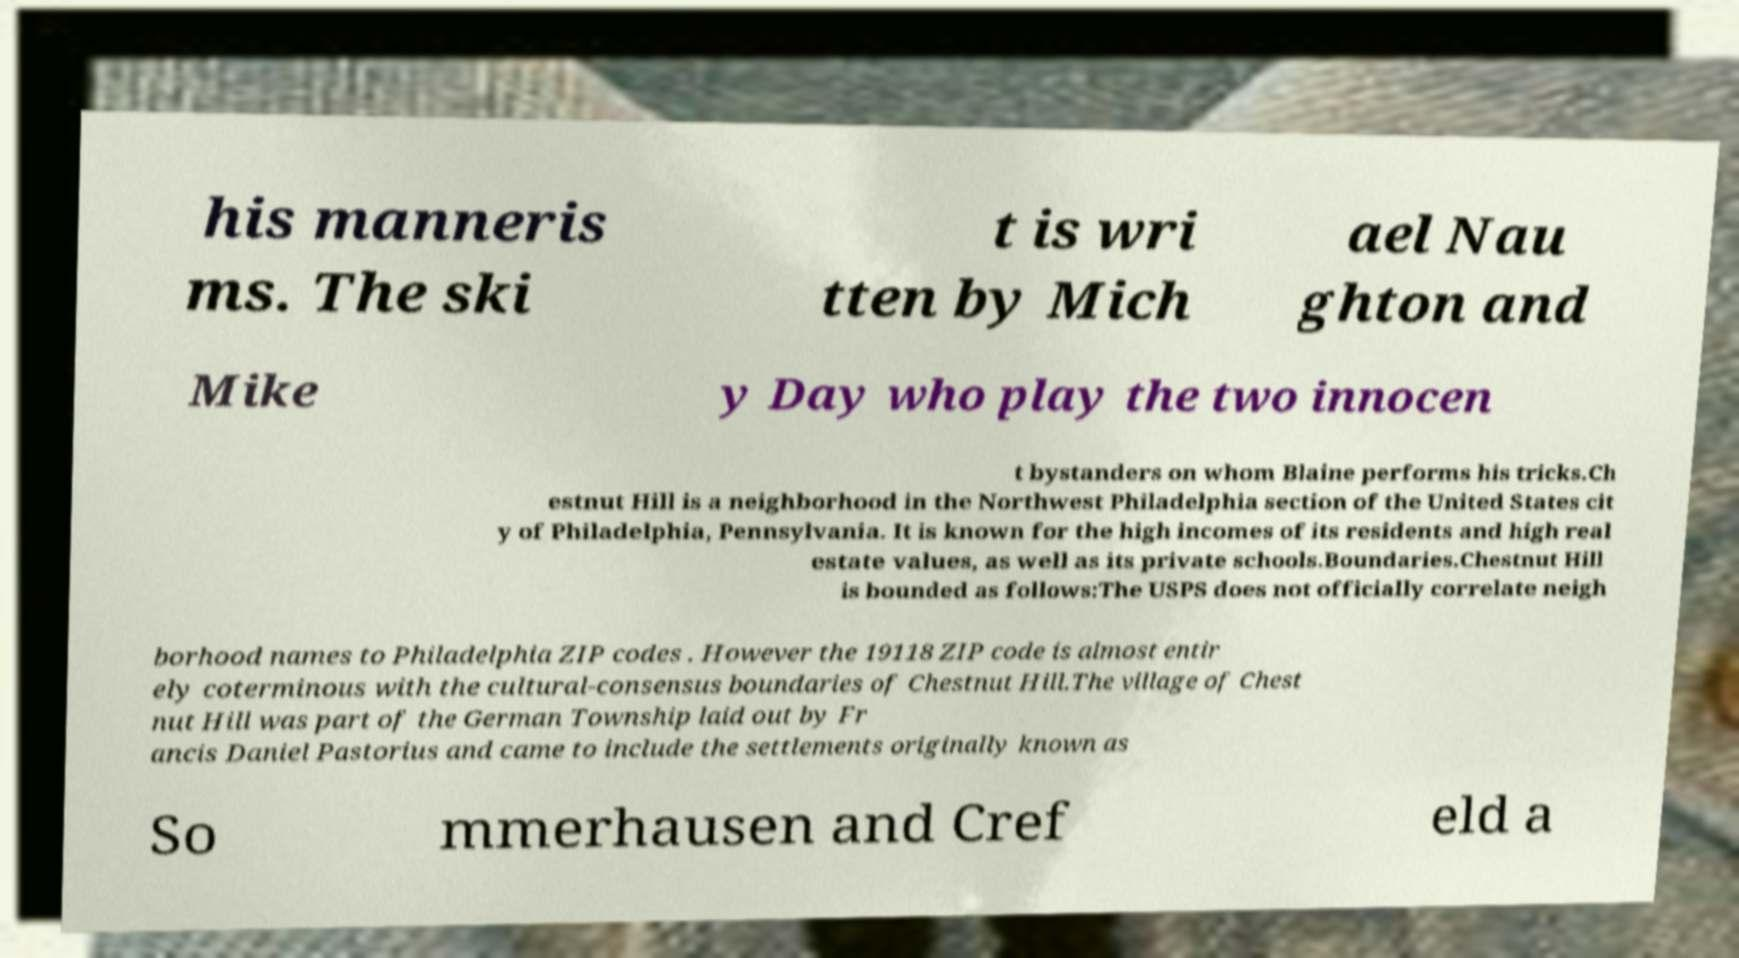Could you assist in decoding the text presented in this image and type it out clearly? his manneris ms. The ski t is wri tten by Mich ael Nau ghton and Mike y Day who play the two innocen t bystanders on whom Blaine performs his tricks.Ch estnut Hill is a neighborhood in the Northwest Philadelphia section of the United States cit y of Philadelphia, Pennsylvania. It is known for the high incomes of its residents and high real estate values, as well as its private schools.Boundaries.Chestnut Hill is bounded as follows:The USPS does not officially correlate neigh borhood names to Philadelphia ZIP codes . However the 19118 ZIP code is almost entir ely coterminous with the cultural-consensus boundaries of Chestnut Hill.The village of Chest nut Hill was part of the German Township laid out by Fr ancis Daniel Pastorius and came to include the settlements originally known as So mmerhausen and Cref eld a 